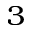<formula> <loc_0><loc_0><loc_500><loc_500>_ { 3 }</formula> 